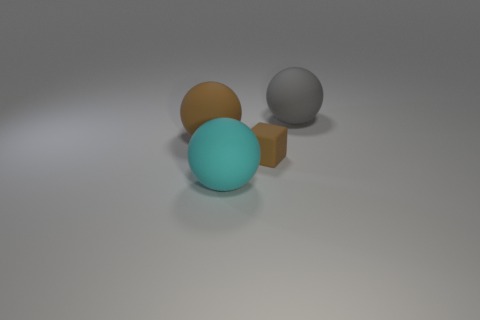What color is the small block?
Give a very brief answer. Brown. Are there fewer matte objects on the right side of the big gray rubber sphere than gray metal blocks?
Your response must be concise. No. Is there anything else that is the same shape as the cyan matte object?
Your response must be concise. Yes. Are there any brown cubes?
Your response must be concise. Yes. Are there fewer tiny cyan shiny cylinders than tiny cubes?
Your answer should be very brief. Yes. What number of tiny cubes have the same material as the small object?
Ensure brevity in your answer.  0. There is a big gray thing; what shape is it?
Offer a terse response. Sphere. What number of objects have the same color as the small block?
Keep it short and to the point. 1. Is there a brown block that has the same size as the gray ball?
Ensure brevity in your answer.  No. What is the material of the brown thing that is the same size as the gray rubber ball?
Provide a succinct answer. Rubber. 